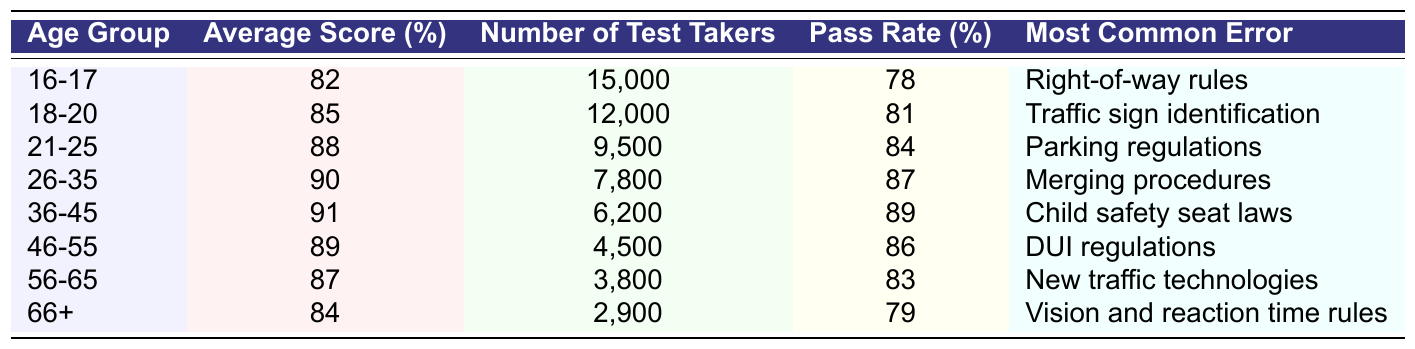What is the average score for the age group 21-25? Referring to the table, the average score for the age group 21-25 is found directly in the corresponding row and column, which is 88%.
Answer: 88% Which age group has the highest pass rate? By examining the pass rates in the table, the age group 36-45 has the highest pass rate at 89%.
Answer: 36-45 What is the most common error made by drivers aged 26-35? The table lists "Merging procedures" as the most common error for the age group 26-35.
Answer: Merging procedures How many test takers were there in the 16-17 age group? The number of test takers for the 16-17 age group is provided in the table as 15,000.
Answer: 15,000 What is the average score for all age groups? To find the average score, add the average scores from each age group: (82 + 85 + 88 + 90 + 91 + 89 + 87 + 84) = 696. Then divide by the number of age groups (8): 696/8 = 87.
Answer: 87 Which age group has the lowest average score, and what is that score? By looking at the average scores, the age group 66+ has the lowest average score, which is 84%.
Answer: 66+, 84% True or False: The age group 56-65 has a higher pass rate than the age group 46-55. Comparing the pass rates in the table, 56-65 has a pass rate of 83%, while 46-55 has a pass rate of 86%. Therefore, the statement is false.
Answer: False What is the difference in average scores between age groups 18-20 and 36-45? The average score for 18-20 is 85% and for 36-45 is 91%. The difference is calculated as 91 - 85 = 6%.
Answer: 6% How many more test takers did the 16-17 age group have compared to the 56-65 age group? The 16-17 age group had 15,000 test takers, while the 56-65 age group had 3,800. The difference is 15,000 - 3,800 = 11,200.
Answer: 11,200 Which error do the youngest drivers struggle with the most, and how does it compare to the most common error among drivers aged 46-55? The youngest drivers (16-17) struggle with "Right-of-way rules," while the 46-55 age group struggles with "DUI regulations." Both are different types of errors, highlighting the varying challenges across age groups.
Answer: Right-of-way rules; Different from DUI regulations What is the average pass rate for all age groups combined? To find the average pass rate, sum all pass rates: (78 + 81 + 84 + 87 + 89 + 86 + 83 + 79) =  748. Dividing by the number of age groups (8) gives us 748/8 = 93.5%.
Answer: 93.5% 